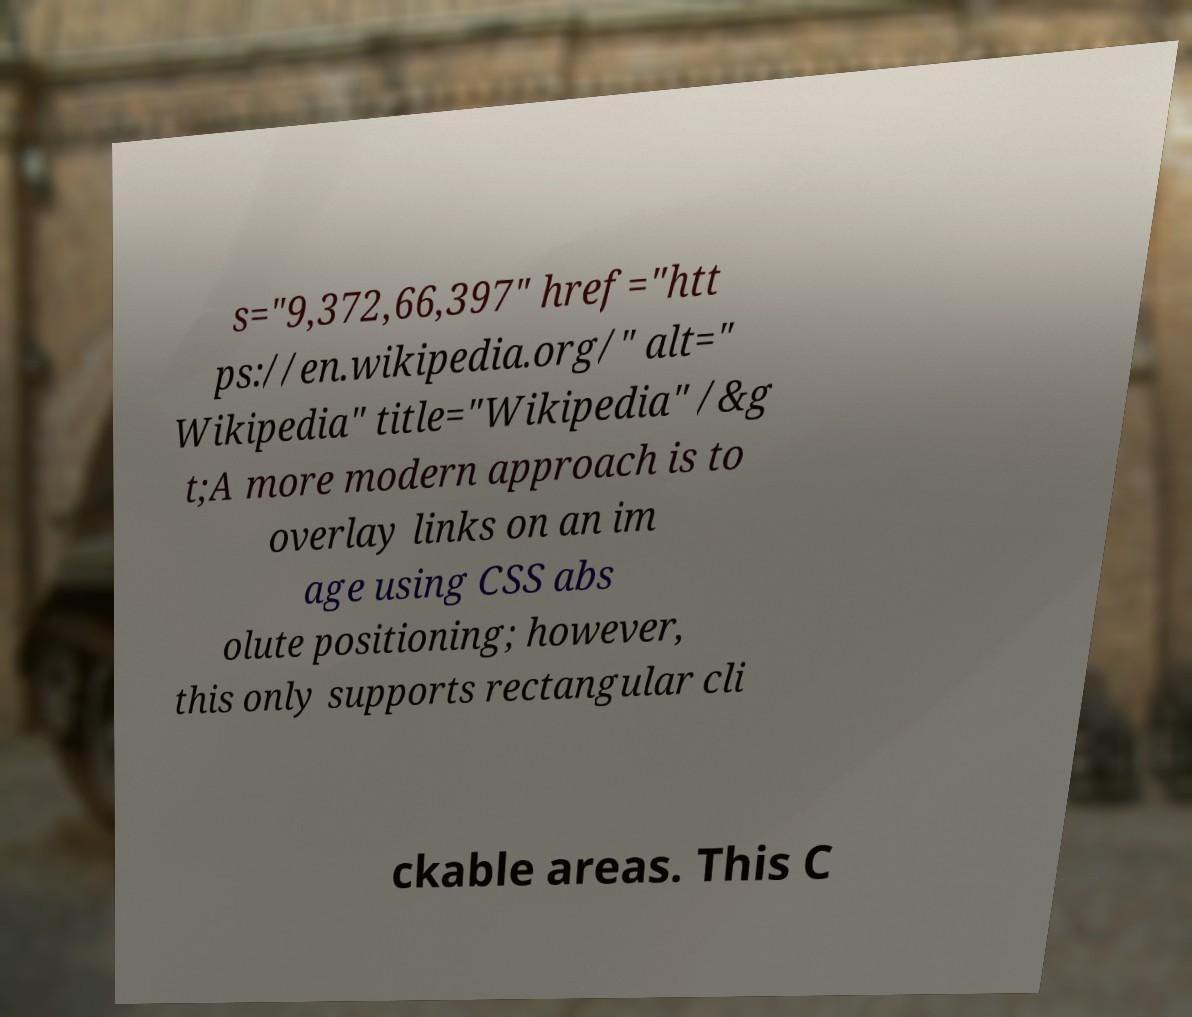What messages or text are displayed in this image? I need them in a readable, typed format. s="9,372,66,397" href="htt ps://en.wikipedia.org/" alt=" Wikipedia" title="Wikipedia" /&g t;A more modern approach is to overlay links on an im age using CSS abs olute positioning; however, this only supports rectangular cli ckable areas. This C 